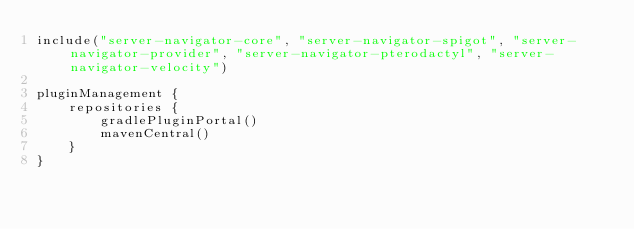<code> <loc_0><loc_0><loc_500><loc_500><_Kotlin_>include("server-navigator-core", "server-navigator-spigot", "server-navigator-provider", "server-navigator-pterodactyl", "server-navigator-velocity")

pluginManagement {
    repositories {
        gradlePluginPortal()
        mavenCentral()
    }
}
</code> 